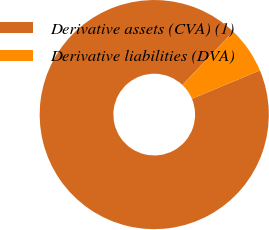Convert chart. <chart><loc_0><loc_0><loc_500><loc_500><pie_chart><fcel>Derivative assets (CVA) (1)<fcel>Derivative liabilities (DVA)<nl><fcel>93.41%<fcel>6.59%<nl></chart> 